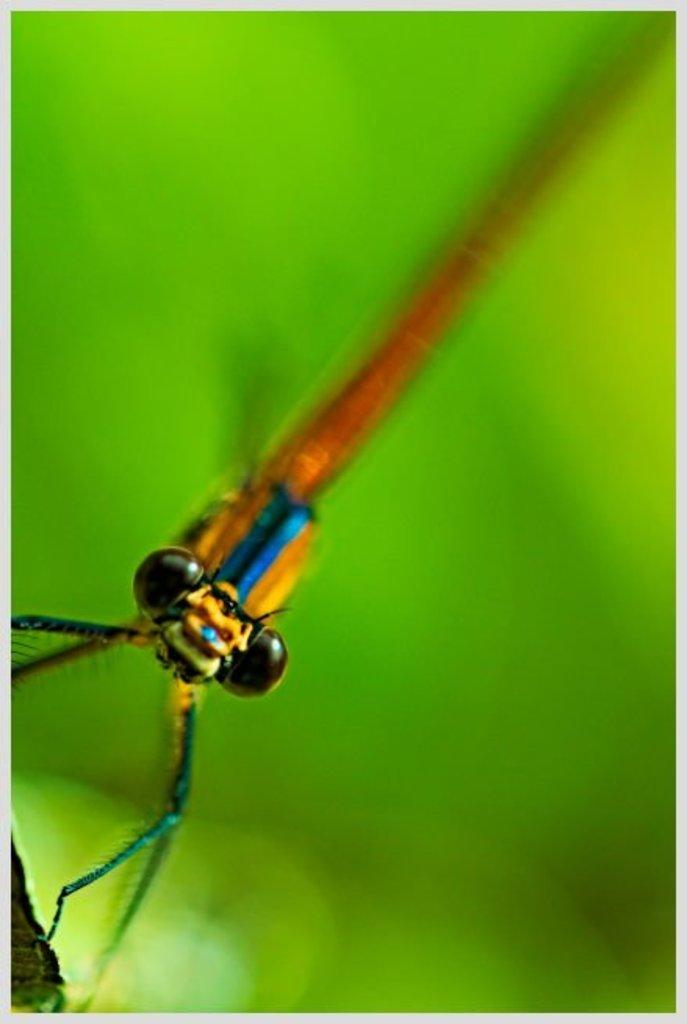What type of creature is present in the image? There is an insect in the image. What can be seen in the background of the image? There is a leaf in the background of the image. How would you describe the background of the image? The background of the image is blurry. What type of voice can be heard coming from the insect in the image? Insects do not have voices, so there is no voice present in the image. 